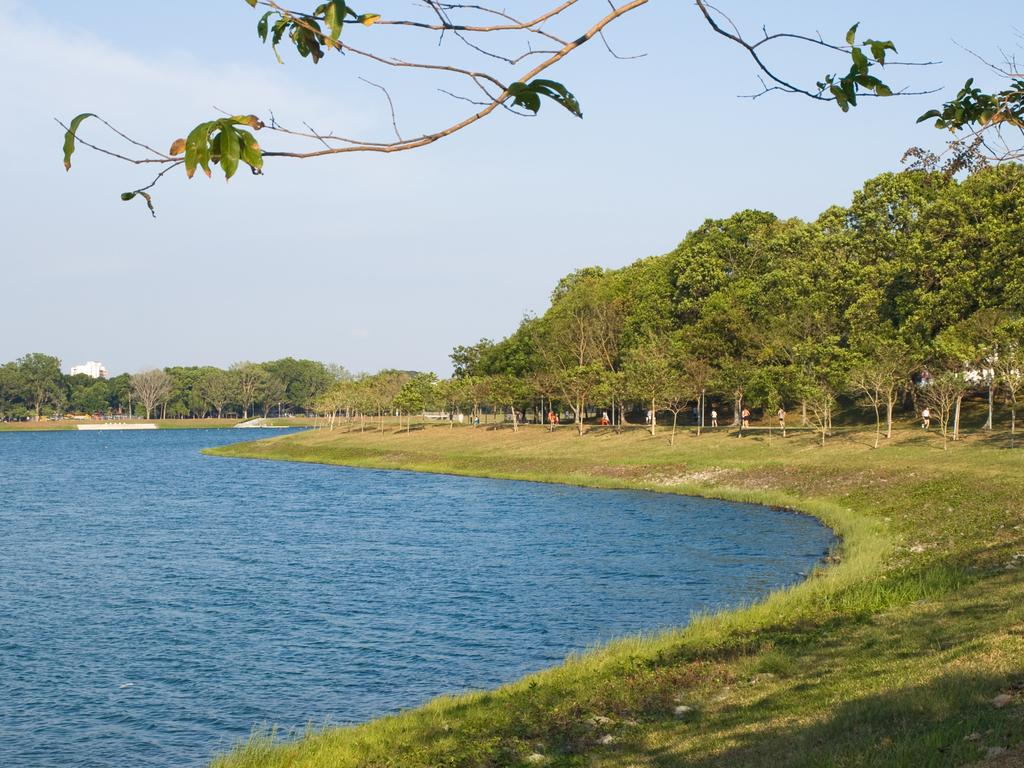What type of body of water is present in the image? There is a lake in the image. What can be seen on the right side of the image? There are trees on the right side of the image. What is visible at the top of the image? The sky is visible at the top of the image. What type of beef is being served in the image? There is no beef present in the image; it features a lake, trees, and the sky. What letters can be seen on the trees in the image? There are no letters visible on the trees in the image. 